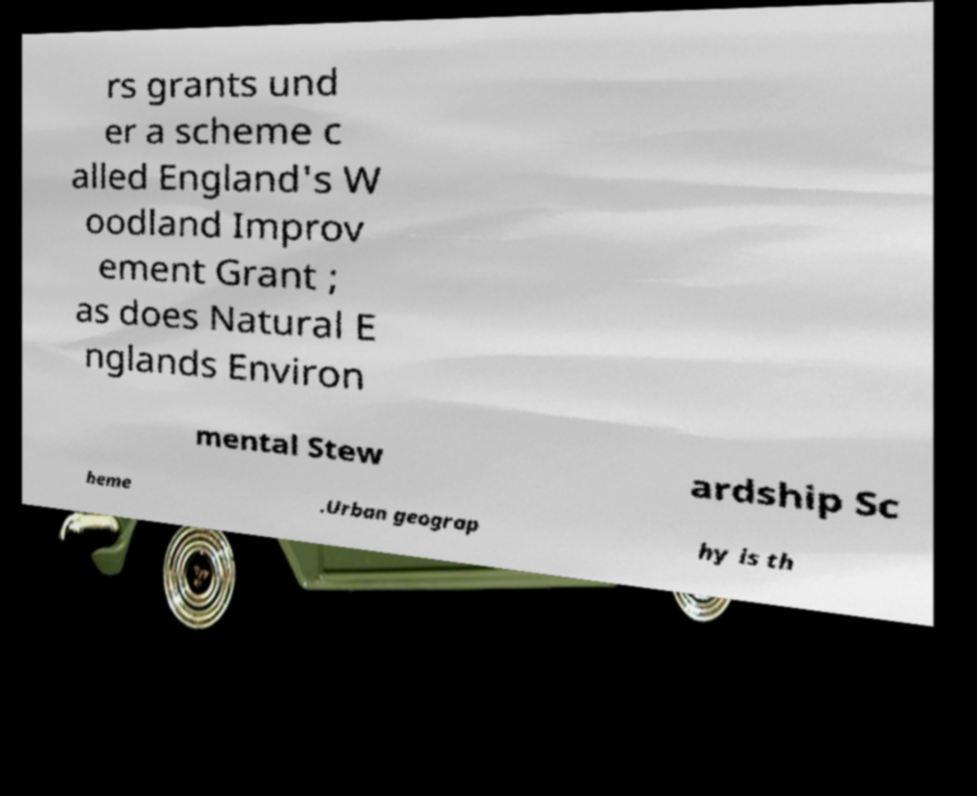Please read and relay the text visible in this image. What does it say? rs grants und er a scheme c alled England's W oodland Improv ement Grant ; as does Natural E nglands Environ mental Stew ardship Sc heme .Urban geograp hy is th 